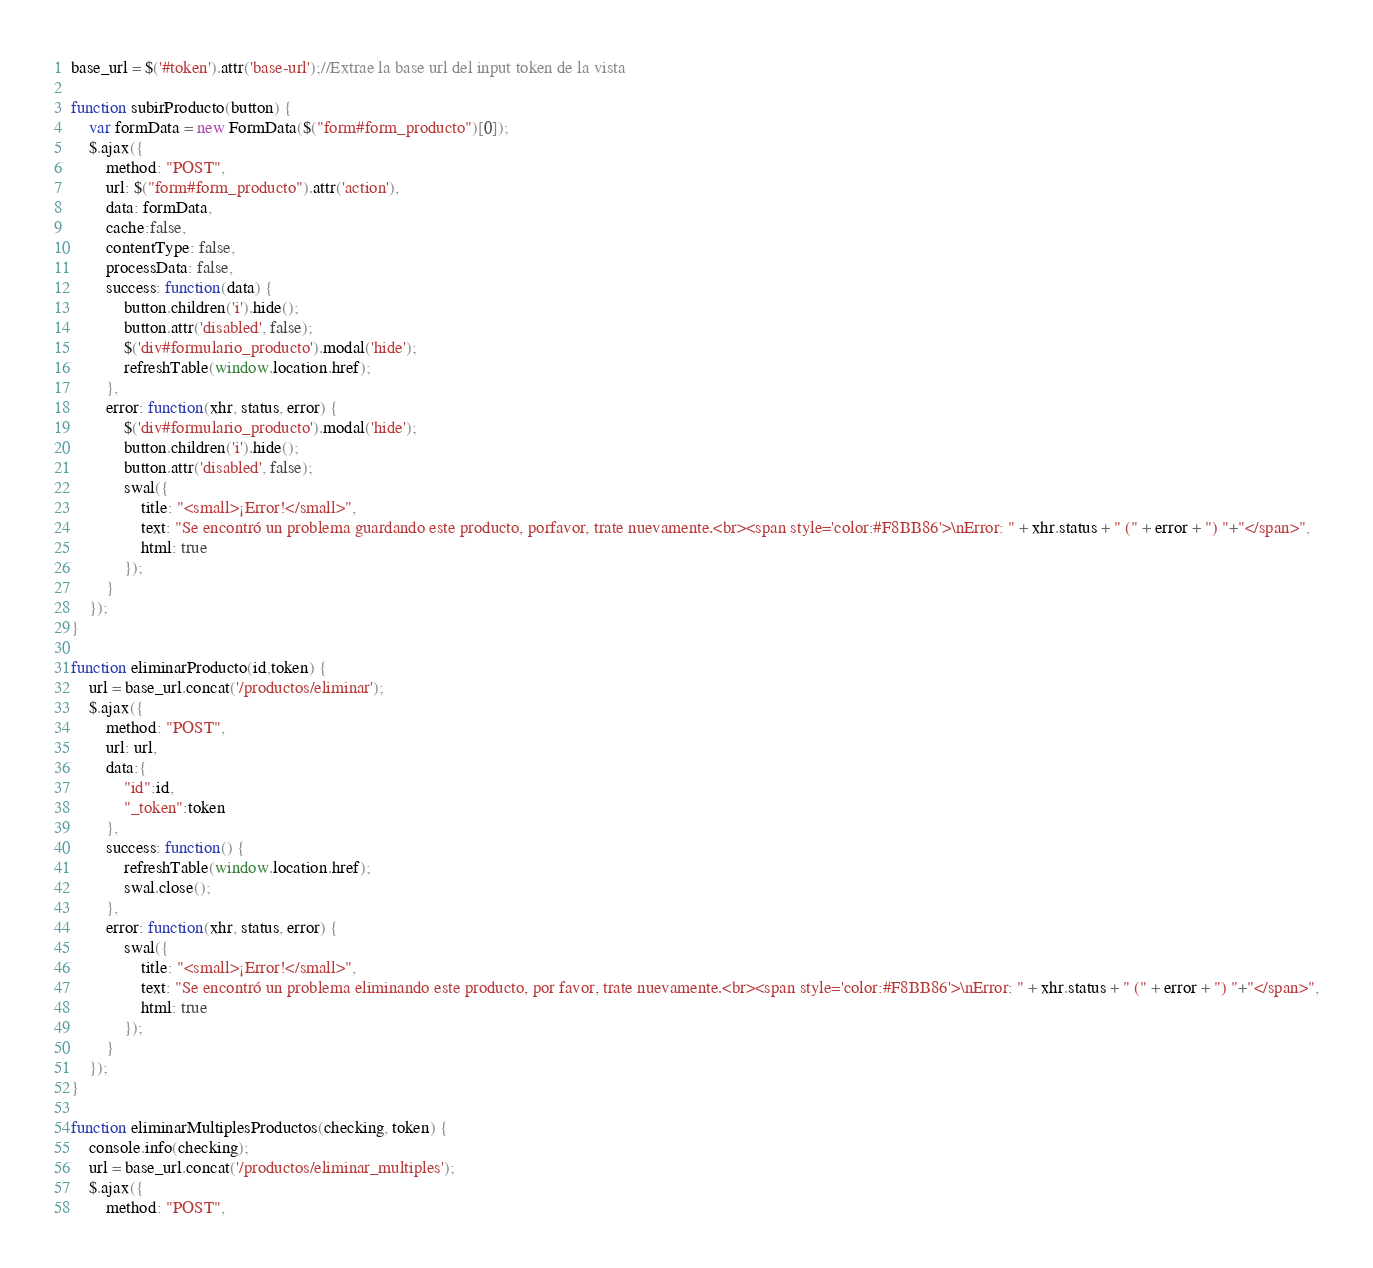<code> <loc_0><loc_0><loc_500><loc_500><_JavaScript_>base_url = $('#token').attr('base-url');//Extrae la base url del input token de la vista

function subirProducto(button) {
    var formData = new FormData($("form#form_producto")[0]);
    $.ajax({
        method: "POST",
        url: $("form#form_producto").attr('action'),
        data: formData,
        cache:false,
        contentType: false,
        processData: false,
        success: function(data) {
            button.children('i').hide();
            button.attr('disabled', false);
            $('div#formulario_producto').modal('hide');
            refreshTable(window.location.href);
        },
        error: function(xhr, status, error) {
            $('div#formulario_producto').modal('hide');
            button.children('i').hide();
            button.attr('disabled', false);
            swal({
                title: "<small>¡Error!</small>",
                text: "Se encontró un problema guardando este producto, porfavor, trate nuevamente.<br><span style='color:#F8BB86'>\nError: " + xhr.status + " (" + error + ") "+"</span>",
                html: true
            });
        }
    });
}

function eliminarProducto(id,token) {
    url = base_url.concat('/productos/eliminar');
    $.ajax({
        method: "POST",
        url: url,
        data:{
            "id":id,
            "_token":token
        },
        success: function() {
            refreshTable(window.location.href);
            swal.close();
        },
        error: function(xhr, status, error) {
            swal({
                title: "<small>¡Error!</small>",
                text: "Se encontró un problema eliminando este producto, por favor, trate nuevamente.<br><span style='color:#F8BB86'>\nError: " + xhr.status + " (" + error + ") "+"</span>",
                html: true
            });
        }
    });
}

function eliminarMultiplesProductos(checking, token) {
    console.info(checking);
    url = base_url.concat('/productos/eliminar_multiples');
    $.ajax({
        method: "POST",</code> 